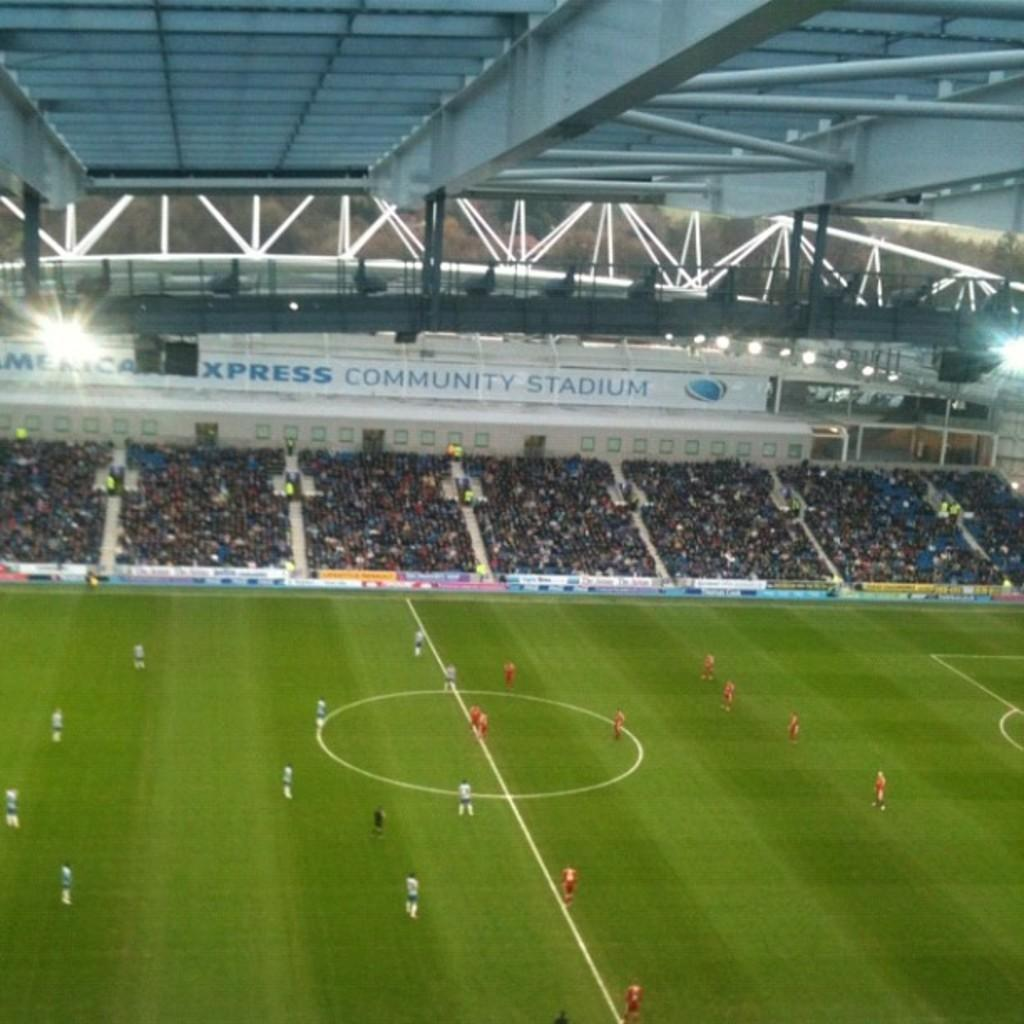Provide a one-sentence caption for the provided image. Soccer players on the field of a packed American Express Community Stadium. 